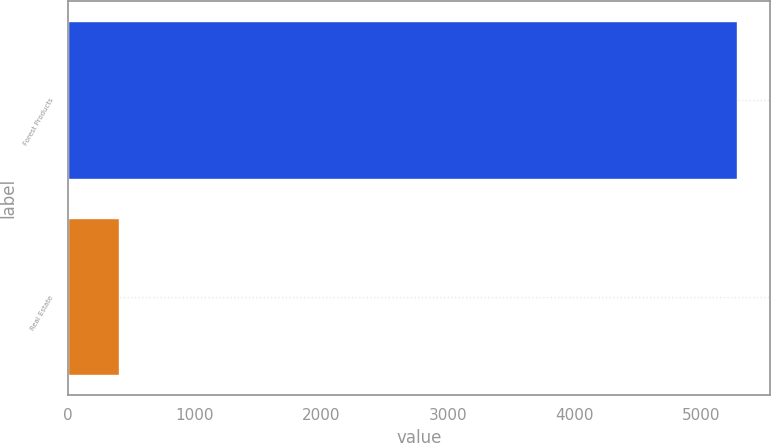<chart> <loc_0><loc_0><loc_500><loc_500><bar_chart><fcel>Forest Products<fcel>Real Estate<nl><fcel>5284<fcel>402<nl></chart> 